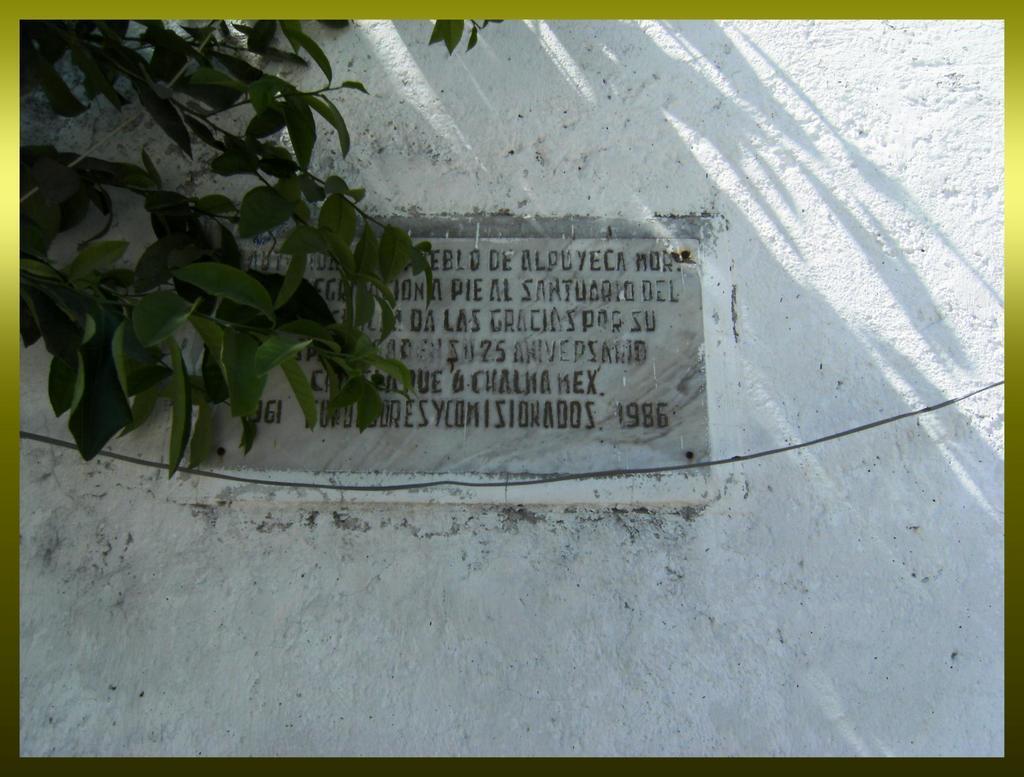Can you describe this image briefly? In this picture I see the wall in front and in the middle of this picture I see something is written and on the left of this image I see the leaves. 